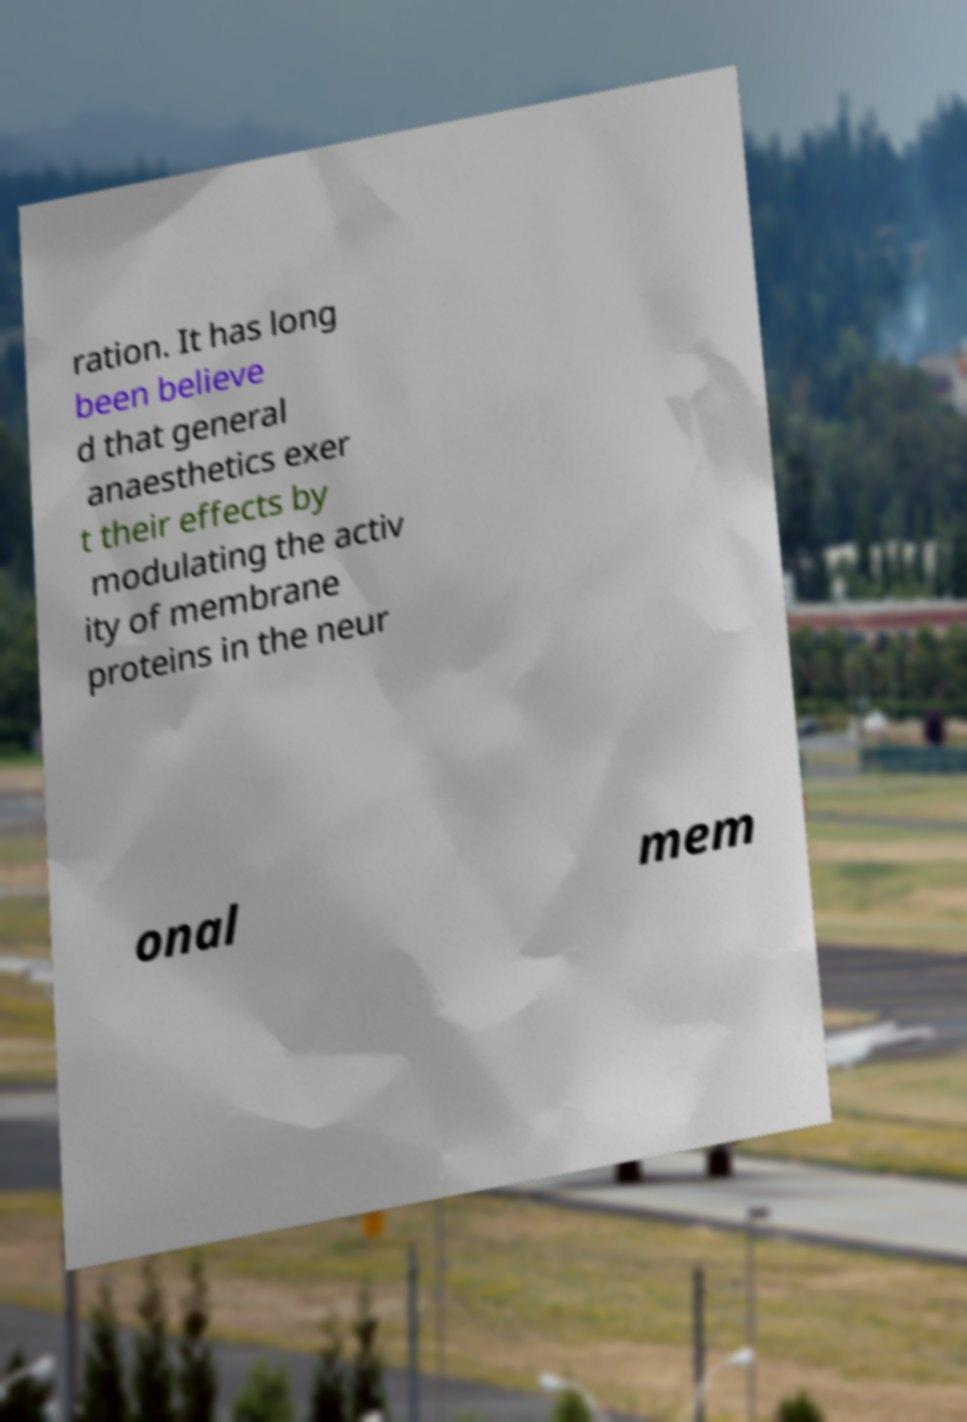Please identify and transcribe the text found in this image. ration. It has long been believe d that general anaesthetics exer t their effects by modulating the activ ity of membrane proteins in the neur onal mem 